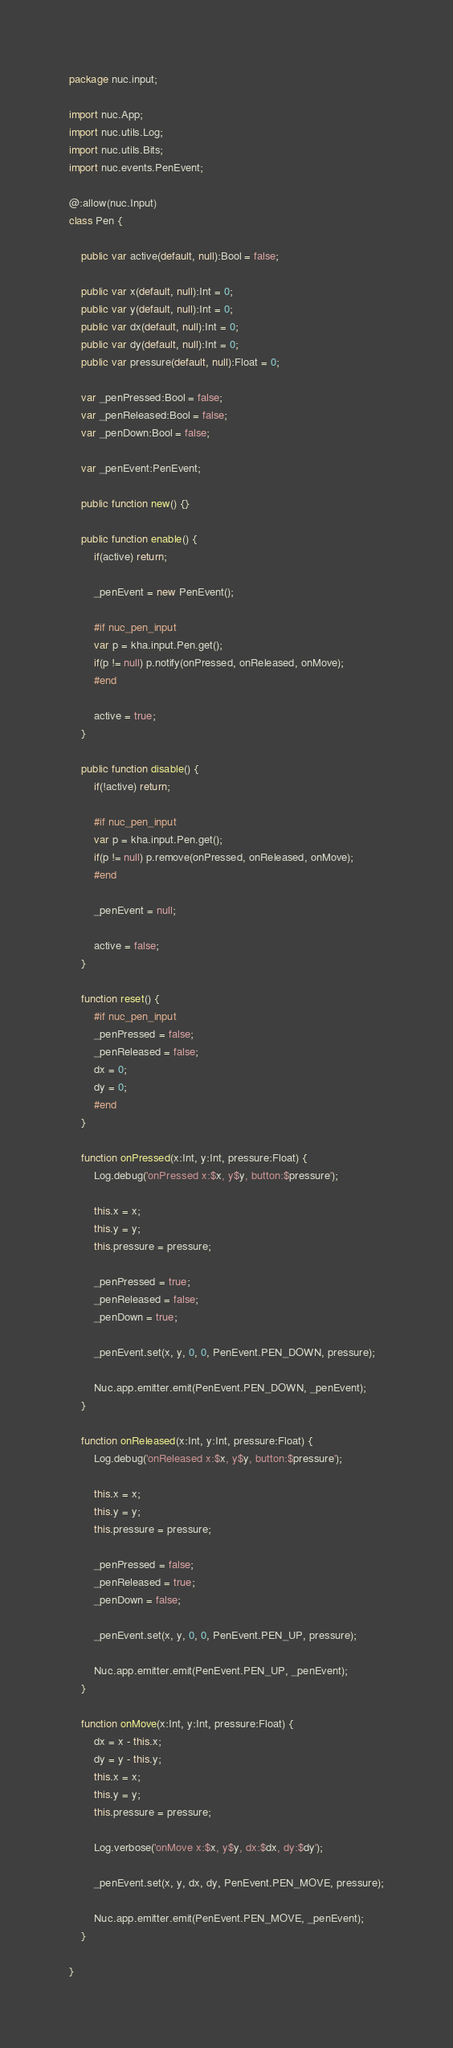<code> <loc_0><loc_0><loc_500><loc_500><_Haxe_>package nuc.input;

import nuc.App;
import nuc.utils.Log;
import nuc.utils.Bits;
import nuc.events.PenEvent;

@:allow(nuc.Input)
class Pen {

	public var active(default, null):Bool = false;
	
	public var x(default, null):Int = 0;
	public var y(default, null):Int = 0;
	public var dx(default, null):Int = 0;
	public var dy(default, null):Int = 0;
	public var pressure(default, null):Float = 0;

	var _penPressed:Bool = false;
	var _penReleased:Bool = false;
	var _penDown:Bool = false;

	var _penEvent:PenEvent;

	public function new() {}

	public function enable() {
		if(active) return;
		
		_penEvent = new PenEvent();
		
		#if nuc_pen_input
		var p = kha.input.Pen.get();
		if(p != null) p.notify(onPressed, onReleased, onMove);
		#end

		active = true;
	}

	public function disable() {
		if(!active) return;
		
		#if nuc_pen_input
		var p = kha.input.Pen.get();
		if(p != null) p.remove(onPressed, onReleased, onMove);
		#end

		_penEvent = null;

		active = false;
	}

	function reset() {
		#if nuc_pen_input
		_penPressed = false;
		_penReleased = false;
		dx = 0;
		dy = 0;
		#end
	}

	function onPressed(x:Int, y:Int, pressure:Float) {
		Log.debug('onPressed x:$x, y$y, button:$pressure');

		this.x = x;
		this.y = y;
		this.pressure = pressure;

		_penPressed = true;
		_penReleased = false;
		_penDown = true;

		_penEvent.set(x, y, 0, 0, PenEvent.PEN_DOWN, pressure);

		Nuc.app.emitter.emit(PenEvent.PEN_DOWN, _penEvent);
	}

	function onReleased(x:Int, y:Int, pressure:Float) {
		Log.debug('onReleased x:$x, y$y, button:$pressure');

		this.x = x;
		this.y = y;
		this.pressure = pressure;

		_penPressed = false;
		_penReleased = true;
		_penDown = false;

		_penEvent.set(x, y, 0, 0, PenEvent.PEN_UP, pressure);

		Nuc.app.emitter.emit(PenEvent.PEN_UP, _penEvent);
	}

	function onMove(x:Int, y:Int, pressure:Float) {
		dx = x - this.x;
		dy = y - this.y;
		this.x = x;
		this.y = y;
		this.pressure = pressure;

		Log.verbose('onMove x:$x, y$y, dx:$dx, dy:$dy');

		_penEvent.set(x, y, dx, dy, PenEvent.PEN_MOVE, pressure);

		Nuc.app.emitter.emit(PenEvent.PEN_MOVE, _penEvent);
	}

}
</code> 